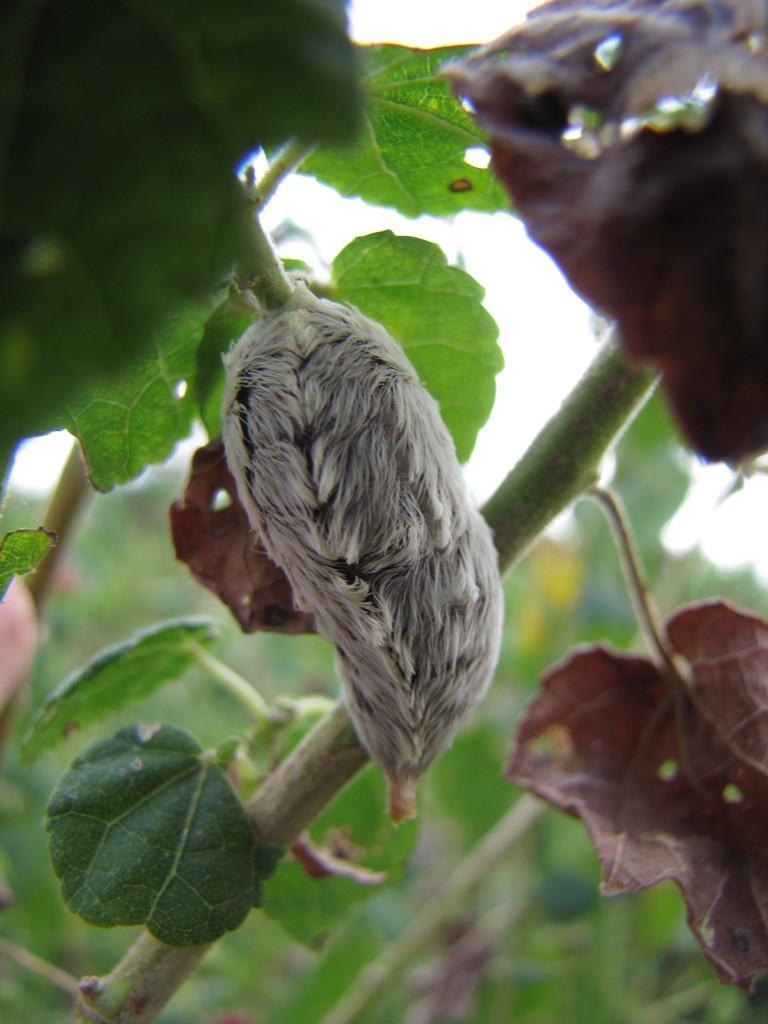Describe this image in one or two sentences. In this picture I can see the pest or flower on the plant. At the bottom I can see some leaves. In the back I can see the sky. 